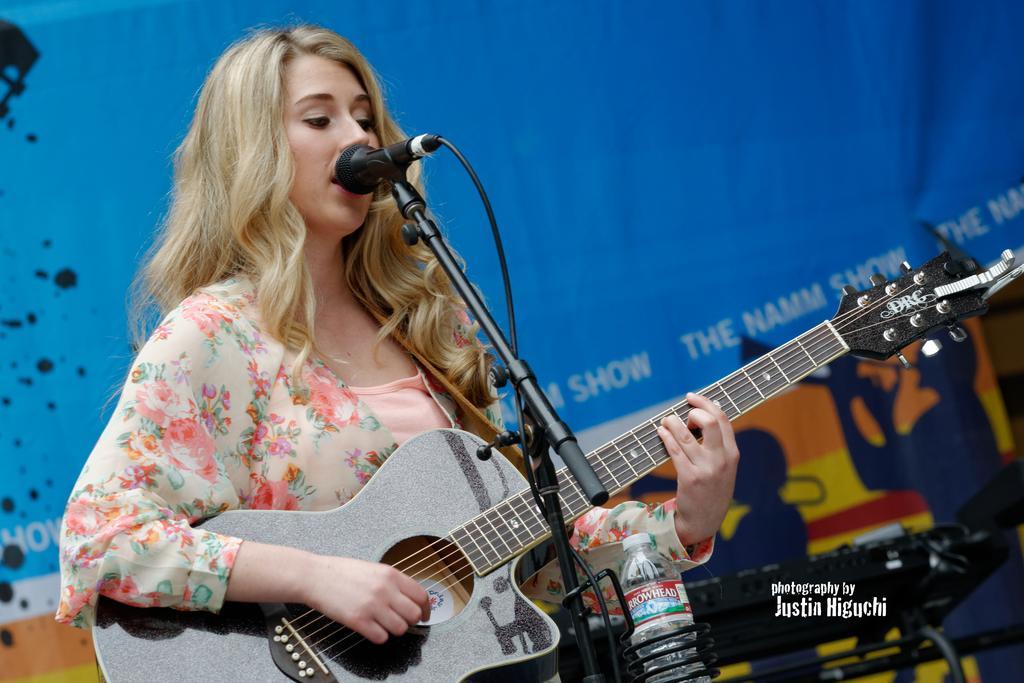Please provide a concise description of this image. In the middle of the image a woman is standing and playing guitar and singing on the microphone. Bottom right side of the image there is a bottle. Behind her there is a banner. 